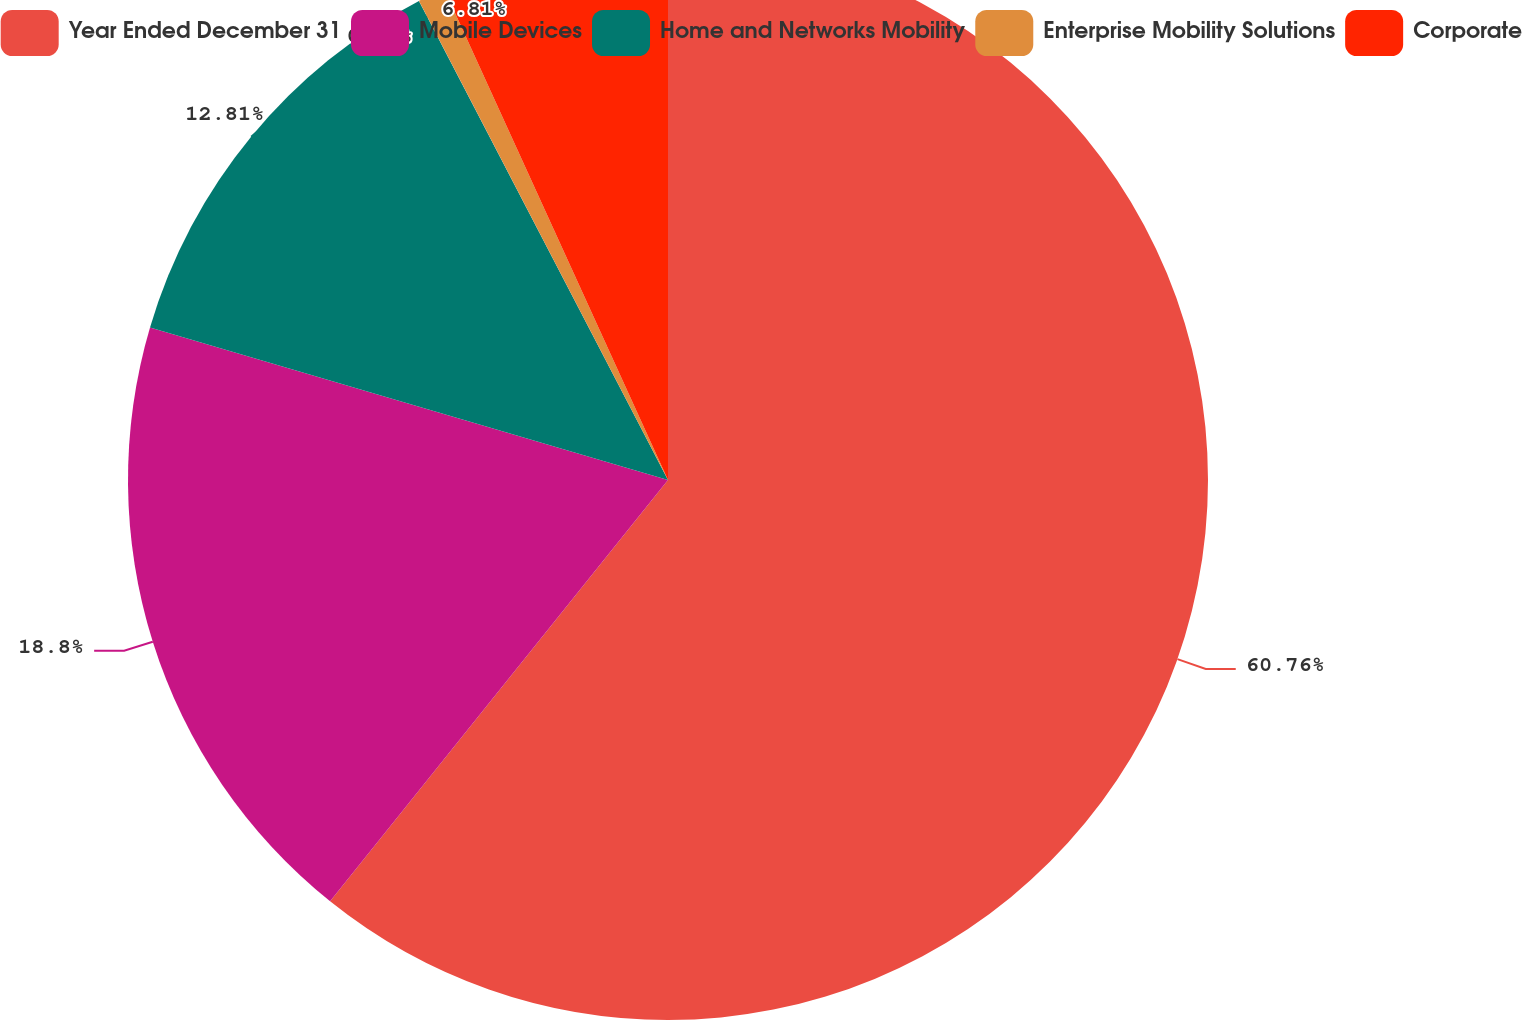Convert chart. <chart><loc_0><loc_0><loc_500><loc_500><pie_chart><fcel>Year Ended December 31<fcel>Mobile Devices<fcel>Home and Networks Mobility<fcel>Enterprise Mobility Solutions<fcel>Corporate<nl><fcel>60.76%<fcel>18.8%<fcel>12.81%<fcel>0.82%<fcel>6.81%<nl></chart> 